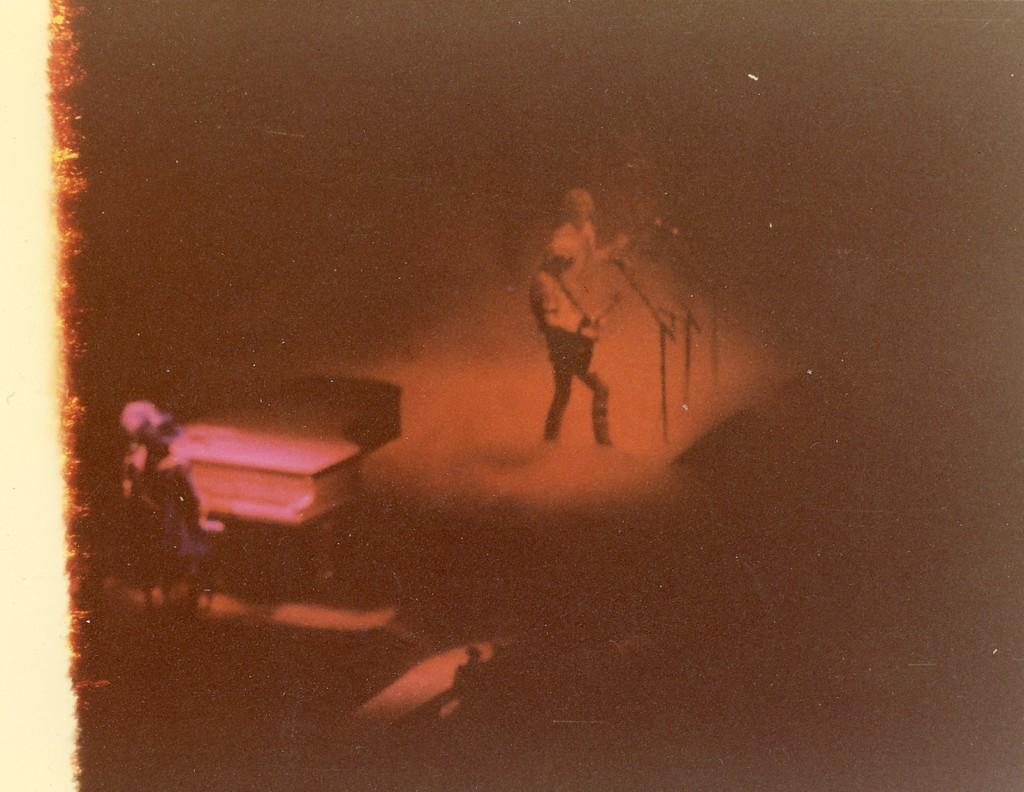What is happening on the stage in the image? There are persons performing on the stage. What type of animals are present in the image? There are mice present in the image. What can be seen in the image that is related to music? There is a musical instrument in the image. Can you describe the position of a person in the image? There is a person sitting in the image. What type of fiction is the person reading to the mice in the image? There is no person reading to the mice in the image, nor is there any fiction present. 